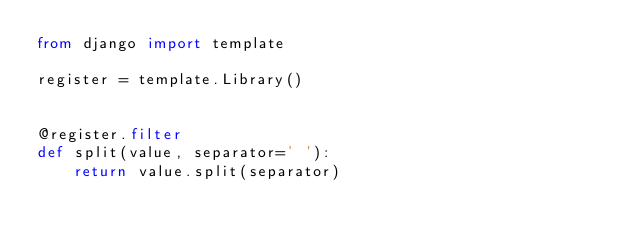Convert code to text. <code><loc_0><loc_0><loc_500><loc_500><_Python_>from django import template

register = template.Library()


@register.filter
def split(value, separator=' '):
    return value.split(separator)</code> 